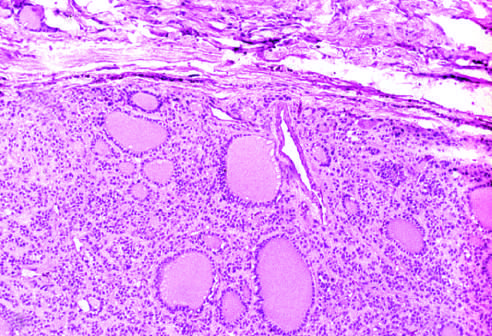s a fibrous capsule seen?
Answer the question using a single word or phrase. Yes 